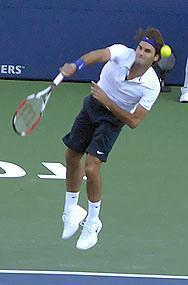How many chairs are there?
Give a very brief answer. 0. 